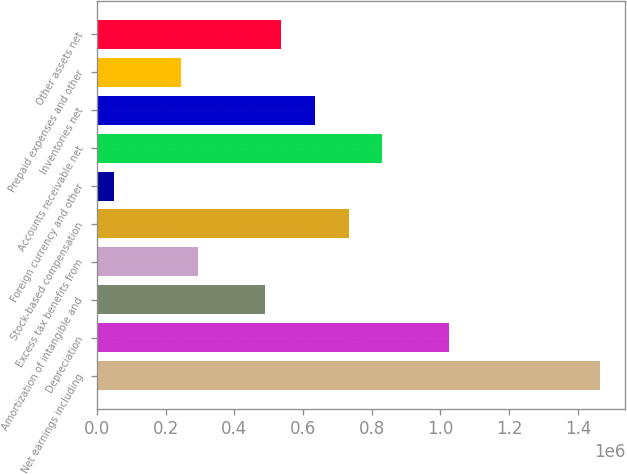Convert chart to OTSL. <chart><loc_0><loc_0><loc_500><loc_500><bar_chart><fcel>Net earnings including<fcel>Depreciation<fcel>Amortization of intangible and<fcel>Excess tax benefits from<fcel>Stock-based compensation<fcel>Foreign currency and other<fcel>Accounts receivable net<fcel>Inventories net<fcel>Prepaid expenses and other<fcel>Other assets net<nl><fcel>1.4646e+06<fcel>1.02528e+06<fcel>488320<fcel>293064<fcel>732390<fcel>48993.1<fcel>830019<fcel>634762<fcel>244250<fcel>537134<nl></chart> 